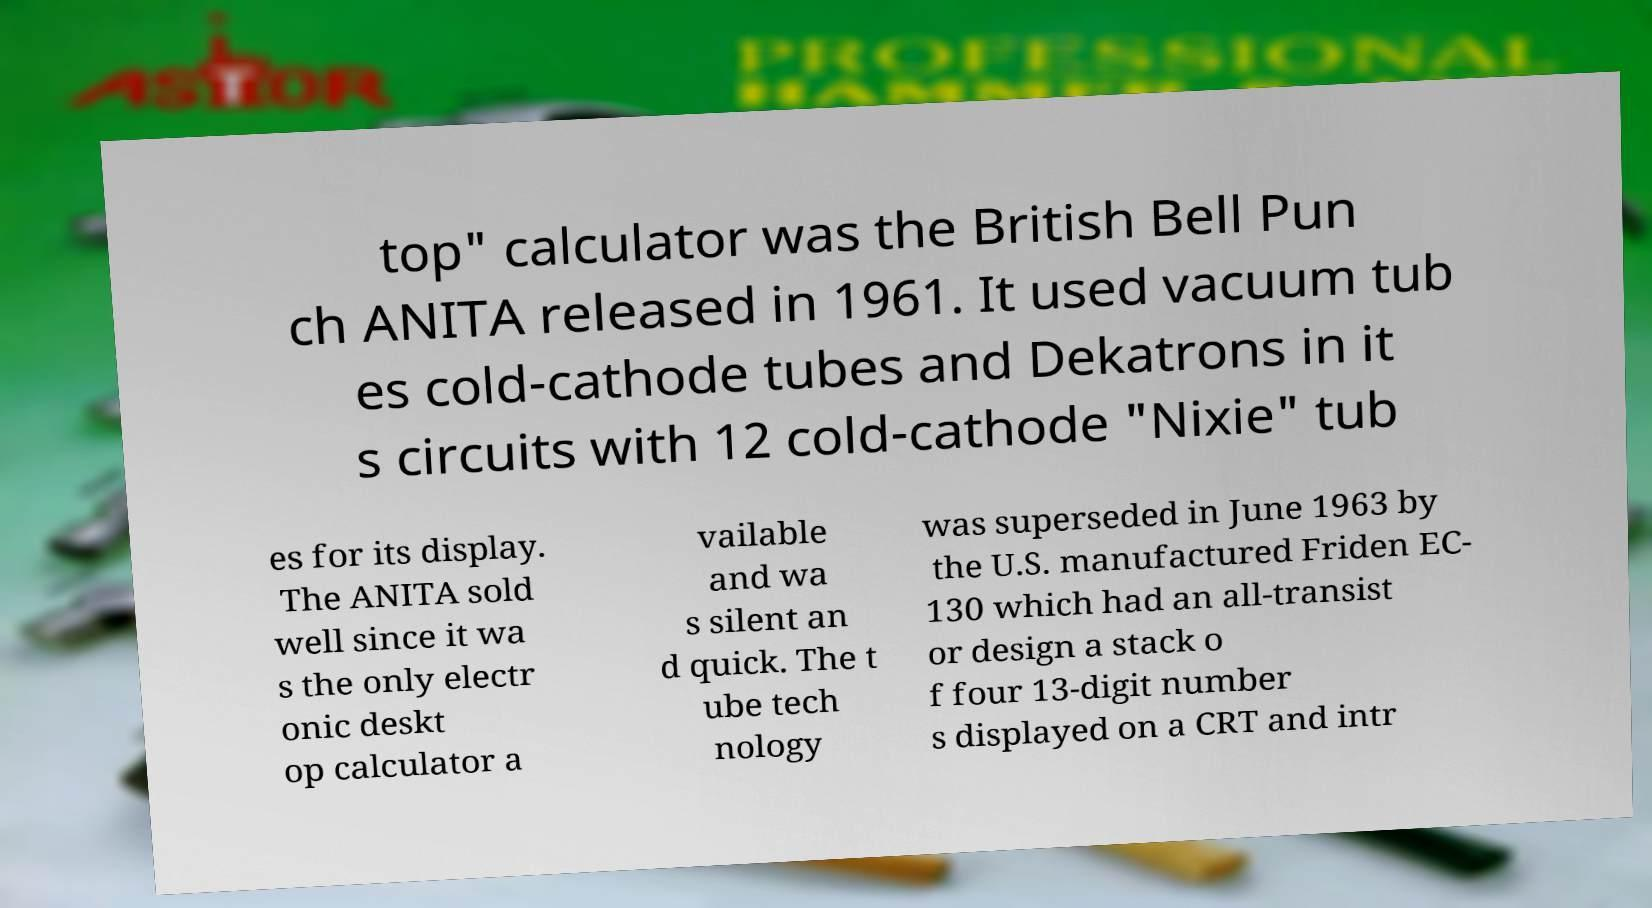I need the written content from this picture converted into text. Can you do that? top" calculator was the British Bell Pun ch ANITA released in 1961. It used vacuum tub es cold-cathode tubes and Dekatrons in it s circuits with 12 cold-cathode "Nixie" tub es for its display. The ANITA sold well since it wa s the only electr onic deskt op calculator a vailable and wa s silent an d quick. The t ube tech nology was superseded in June 1963 by the U.S. manufactured Friden EC- 130 which had an all-transist or design a stack o f four 13-digit number s displayed on a CRT and intr 